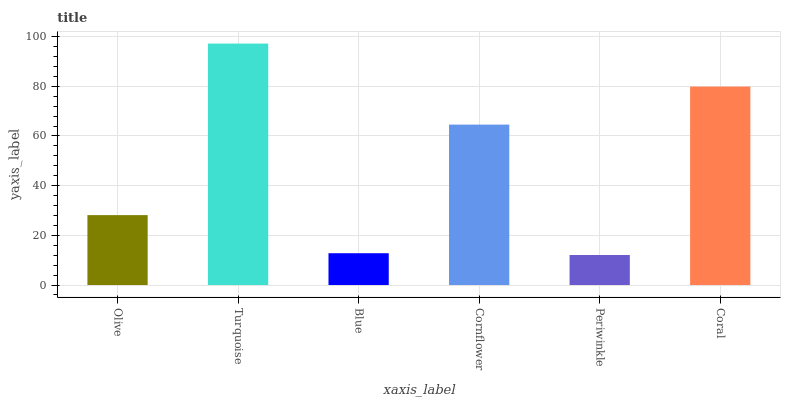Is Periwinkle the minimum?
Answer yes or no. Yes. Is Turquoise the maximum?
Answer yes or no. Yes. Is Blue the minimum?
Answer yes or no. No. Is Blue the maximum?
Answer yes or no. No. Is Turquoise greater than Blue?
Answer yes or no. Yes. Is Blue less than Turquoise?
Answer yes or no. Yes. Is Blue greater than Turquoise?
Answer yes or no. No. Is Turquoise less than Blue?
Answer yes or no. No. Is Cornflower the high median?
Answer yes or no. Yes. Is Olive the low median?
Answer yes or no. Yes. Is Periwinkle the high median?
Answer yes or no. No. Is Periwinkle the low median?
Answer yes or no. No. 